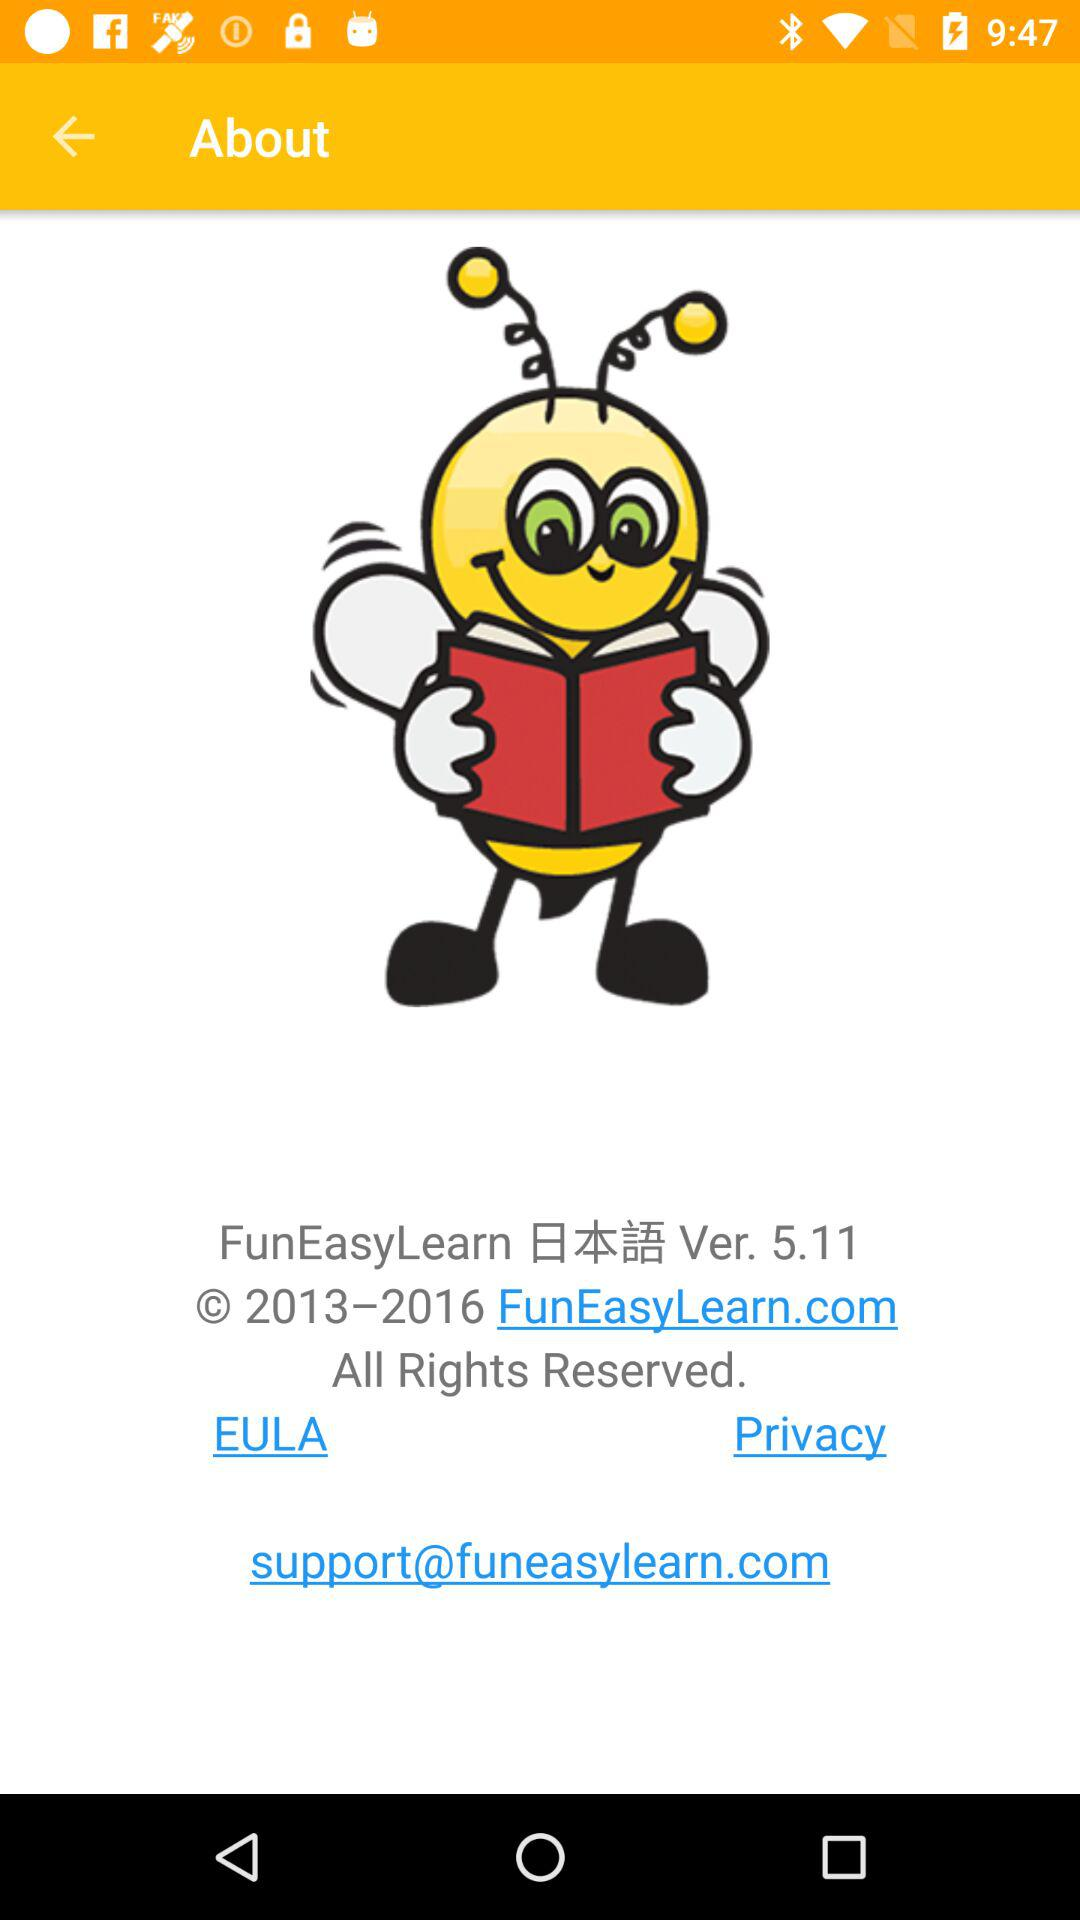What is the support email? The support email is support@funeasylearn.com. 